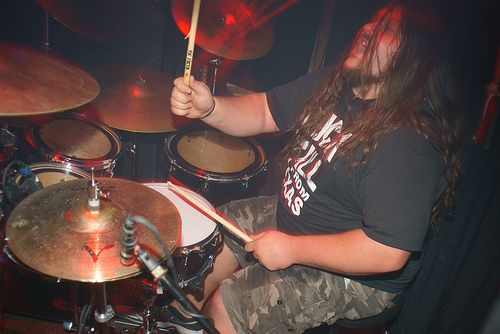<image>
Is the shorts behind the symbol? Yes. From this viewpoint, the shorts is positioned behind the symbol, with the symbol partially or fully occluding the shorts. 